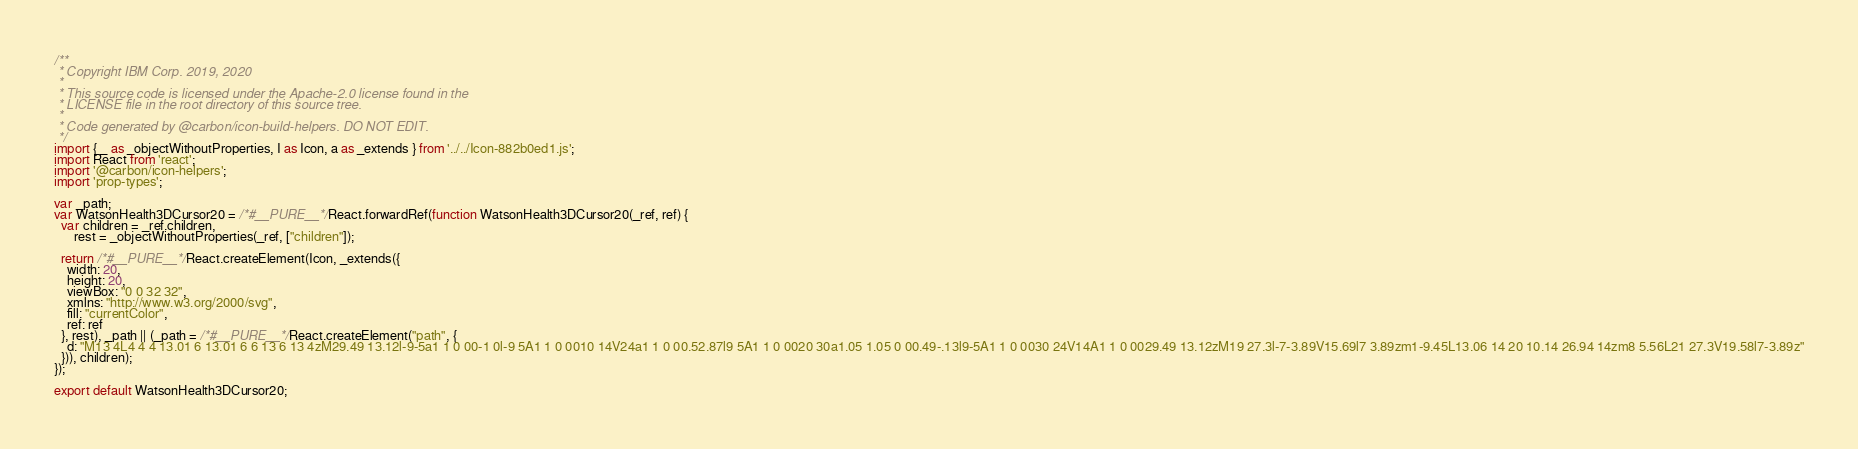<code> <loc_0><loc_0><loc_500><loc_500><_JavaScript_>/**
 * Copyright IBM Corp. 2019, 2020
 *
 * This source code is licensed under the Apache-2.0 license found in the
 * LICENSE file in the root directory of this source tree.
 *
 * Code generated by @carbon/icon-build-helpers. DO NOT EDIT.
 */
import { _ as _objectWithoutProperties, I as Icon, a as _extends } from '../../Icon-882b0ed1.js';
import React from 'react';
import '@carbon/icon-helpers';
import 'prop-types';

var _path;
var WatsonHealth3DCursor20 = /*#__PURE__*/React.forwardRef(function WatsonHealth3DCursor20(_ref, ref) {
  var children = _ref.children,
      rest = _objectWithoutProperties(_ref, ["children"]);

  return /*#__PURE__*/React.createElement(Icon, _extends({
    width: 20,
    height: 20,
    viewBox: "0 0 32 32",
    xmlns: "http://www.w3.org/2000/svg",
    fill: "currentColor",
    ref: ref
  }, rest), _path || (_path = /*#__PURE__*/React.createElement("path", {
    d: "M13 4L4 4 4 13.01 6 13.01 6 6 13 6 13 4zM29.49 13.12l-9-5a1 1 0 00-1 0l-9 5A1 1 0 0010 14V24a1 1 0 00.52.87l9 5A1 1 0 0020 30a1.05 1.05 0 00.49-.13l9-5A1 1 0 0030 24V14A1 1 0 0029.49 13.12zM19 27.3l-7-3.89V15.69l7 3.89zm1-9.45L13.06 14 20 10.14 26.94 14zm8 5.56L21 27.3V19.58l7-3.89z"
  })), children);
});

export default WatsonHealth3DCursor20;
</code> 